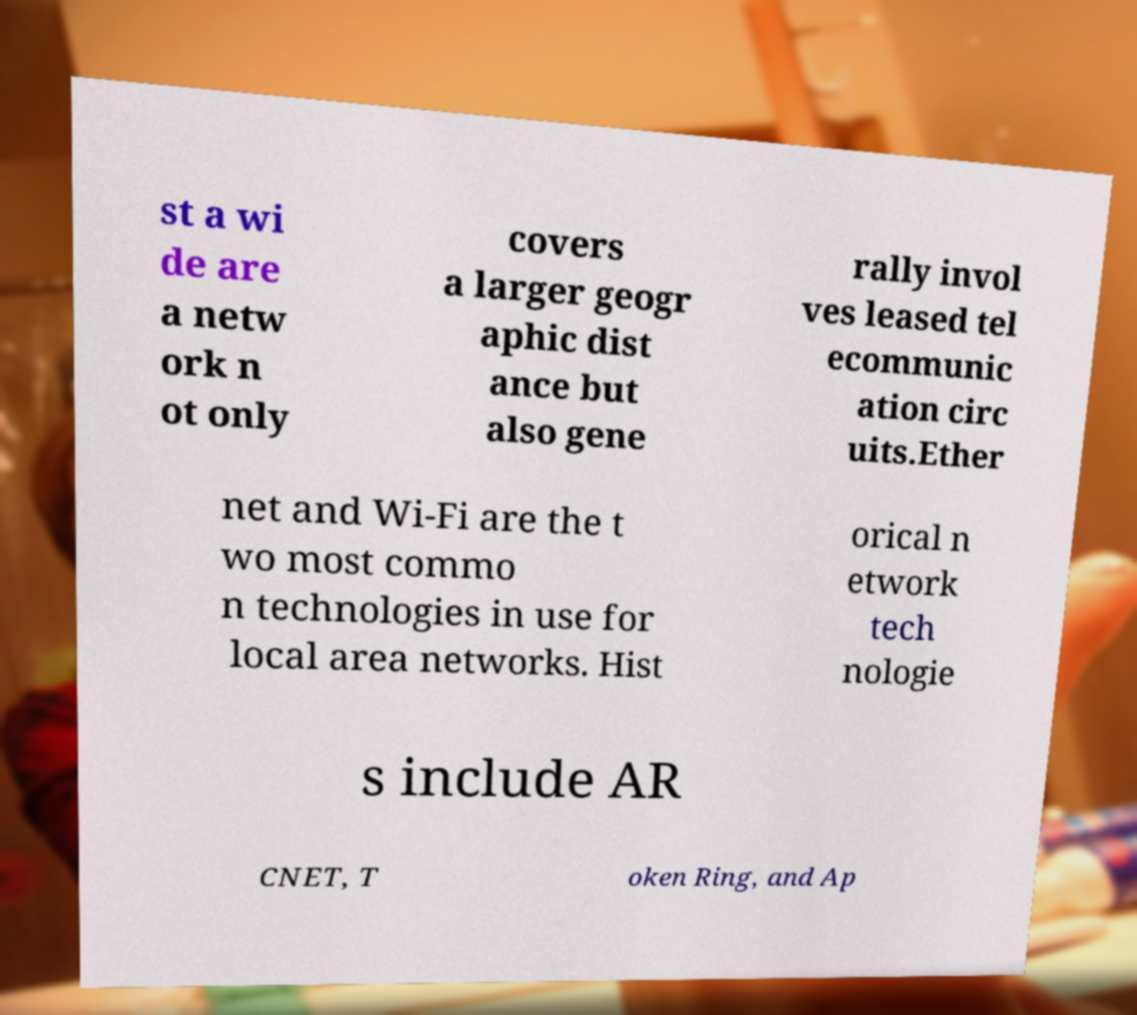Can you accurately transcribe the text from the provided image for me? st a wi de are a netw ork n ot only covers a larger geogr aphic dist ance but also gene rally invol ves leased tel ecommunic ation circ uits.Ether net and Wi-Fi are the t wo most commo n technologies in use for local area networks. Hist orical n etwork tech nologie s include AR CNET, T oken Ring, and Ap 